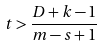<formula> <loc_0><loc_0><loc_500><loc_500>t > \frac { D + k - 1 } { m - s + 1 }</formula> 